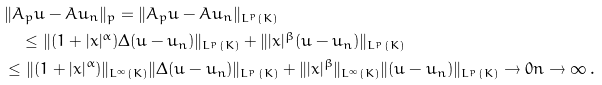<formula> <loc_0><loc_0><loc_500><loc_500>& \| A _ { p } u - A u _ { n } \| _ { p } = \| A _ { p } u - A u _ { n } \| _ { L ^ { p } ( K ) } \\ & \quad \leq \| ( 1 + | x | ^ { \alpha } ) \Delta ( u - u _ { n } ) \| _ { L ^ { p } ( K ) } + \| | x | ^ { \beta } ( u - u _ { n } ) \| _ { L ^ { p } ( K ) } \\ & \leq \| ( 1 + | x | ^ { \alpha } ) \| _ { L ^ { \infty } ( K ) } \| \Delta ( u - u _ { n } ) \| _ { L ^ { p } ( K ) } + \| | x | ^ { \beta } \| _ { L ^ { \infty } ( K ) } \| ( u - u _ { n } ) \| _ { L ^ { p } ( K ) } \to 0 n \to \infty \, .</formula> 